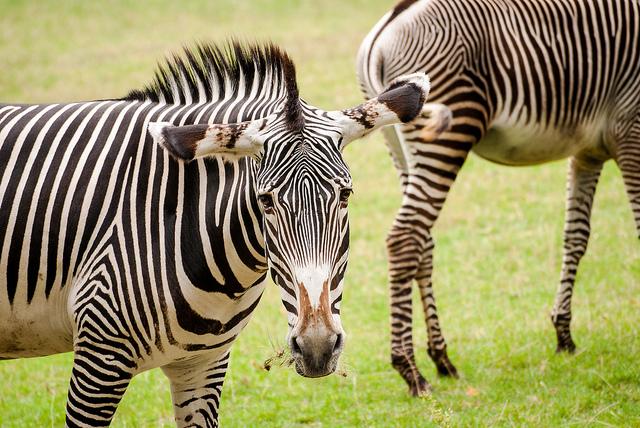Is this at nighttime?
Answer briefly. No. Is this a giraffe?
Give a very brief answer. No. Where is the zebra looking?
Be succinct. At camera. 